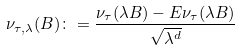Convert formula to latex. <formula><loc_0><loc_0><loc_500><loc_500>\nu _ { \tau , \lambda } ( B ) \colon = \frac { \nu _ { \tau } ( \lambda B ) - E \nu _ { \tau } ( \lambda B ) } { \sqrt { \lambda ^ { d } } }</formula> 